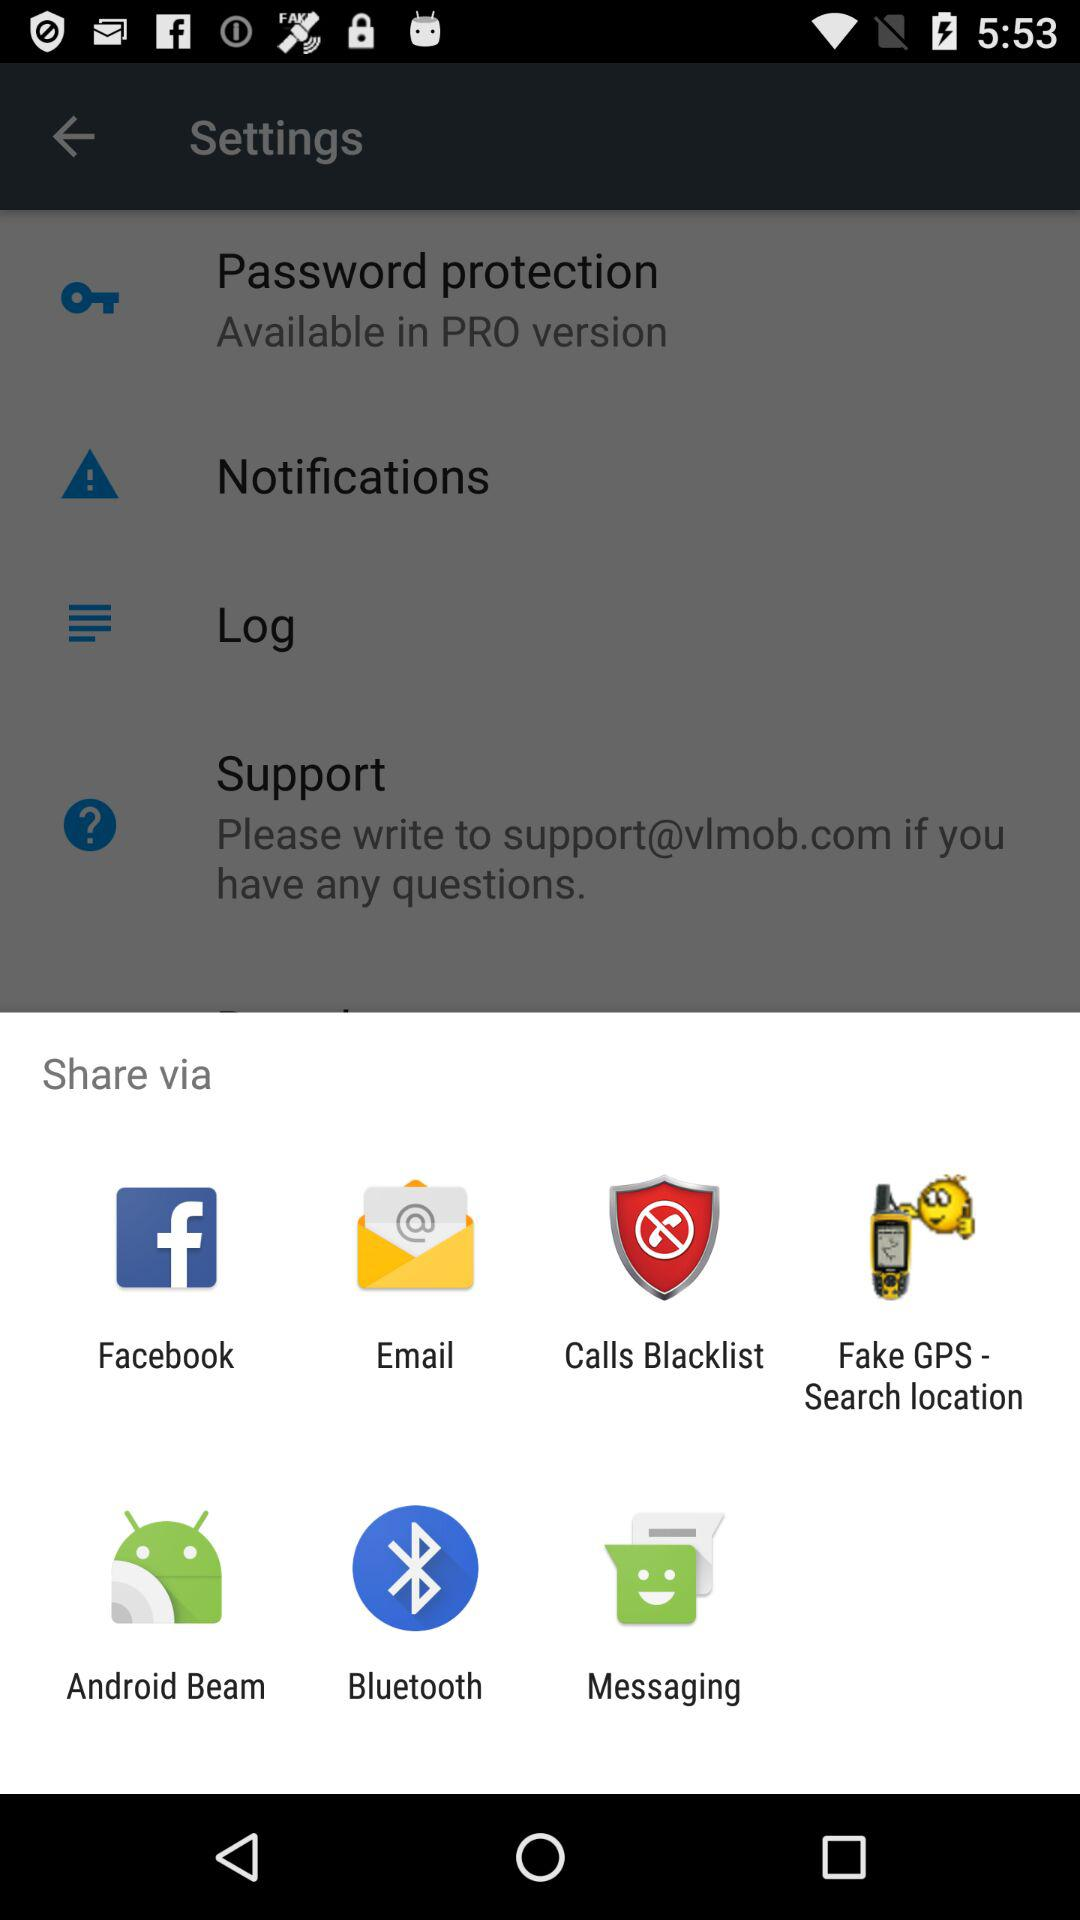How many items in the settings menu are available in the PRO version?
Answer the question using a single word or phrase. 1 